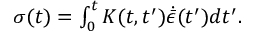<formula> <loc_0><loc_0><loc_500><loc_500>\begin{array} { r } { \sigma ( t ) = \int _ { 0 } ^ { t } K ( t , t ^ { \prime } ) \dot { { \bar { \epsilon } } } ( t ^ { \prime } ) d t ^ { \prime } . } \end{array}</formula> 